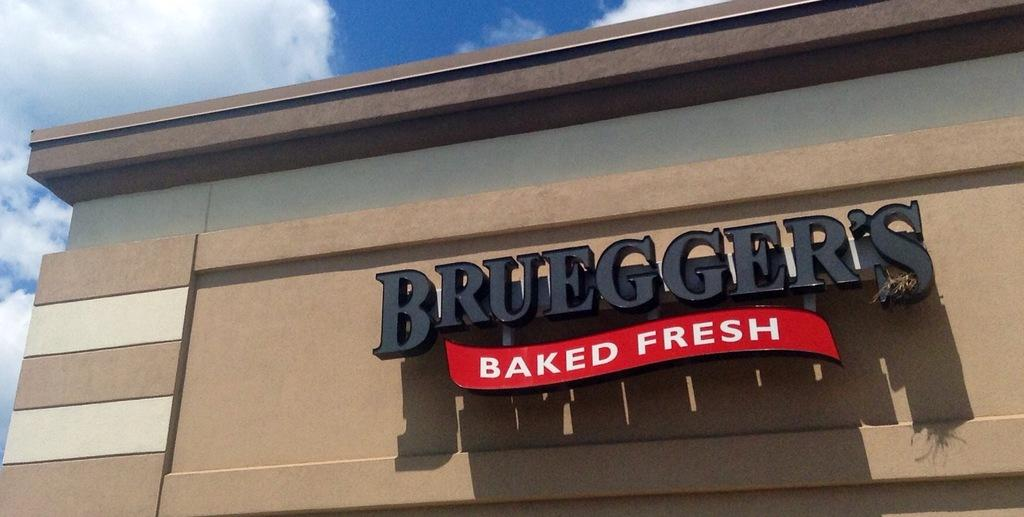What is on the building in the image? There is a name board on a building in the image. What is visible in the background of the image? The sky is visible in the background of the image. What can be seen in the sky in the image? There are clouds in the sky. What type of skin powder is visible on the name board in the image? There is no skin powder present on the name board in the image. What emotion does the name board express towards the clouds in the image? The name board is an inanimate object and does not express emotions. 